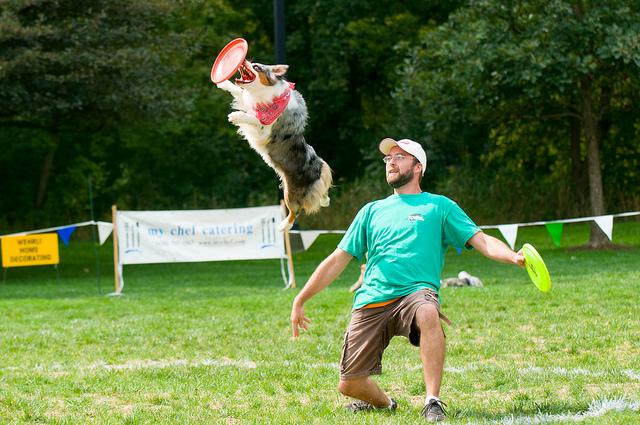What kind of service does the white sign promise? Please explain your reasoning. food prep. It is a sign for a catering company that would cater events and such. 